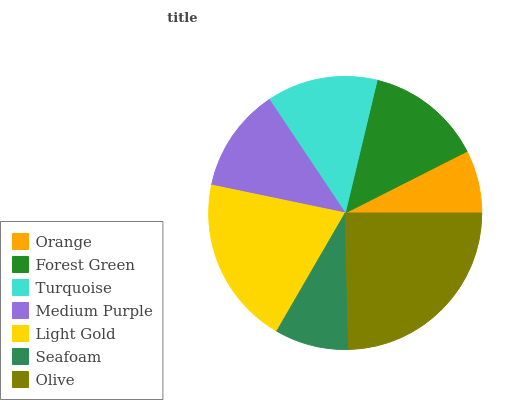Is Orange the minimum?
Answer yes or no. Yes. Is Olive the maximum?
Answer yes or no. Yes. Is Forest Green the minimum?
Answer yes or no. No. Is Forest Green the maximum?
Answer yes or no. No. Is Forest Green greater than Orange?
Answer yes or no. Yes. Is Orange less than Forest Green?
Answer yes or no. Yes. Is Orange greater than Forest Green?
Answer yes or no. No. Is Forest Green less than Orange?
Answer yes or no. No. Is Turquoise the high median?
Answer yes or no. Yes. Is Turquoise the low median?
Answer yes or no. Yes. Is Medium Purple the high median?
Answer yes or no. No. Is Seafoam the low median?
Answer yes or no. No. 